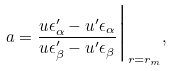<formula> <loc_0><loc_0><loc_500><loc_500>a = \frac { u \epsilon _ { \alpha } ^ { \prime } - u ^ { \prime } \epsilon _ { \alpha } } { u \epsilon _ { \beta } ^ { \prime } - u ^ { \prime } \epsilon _ { \beta } } \Big | _ { r = r _ { m } } ,</formula> 